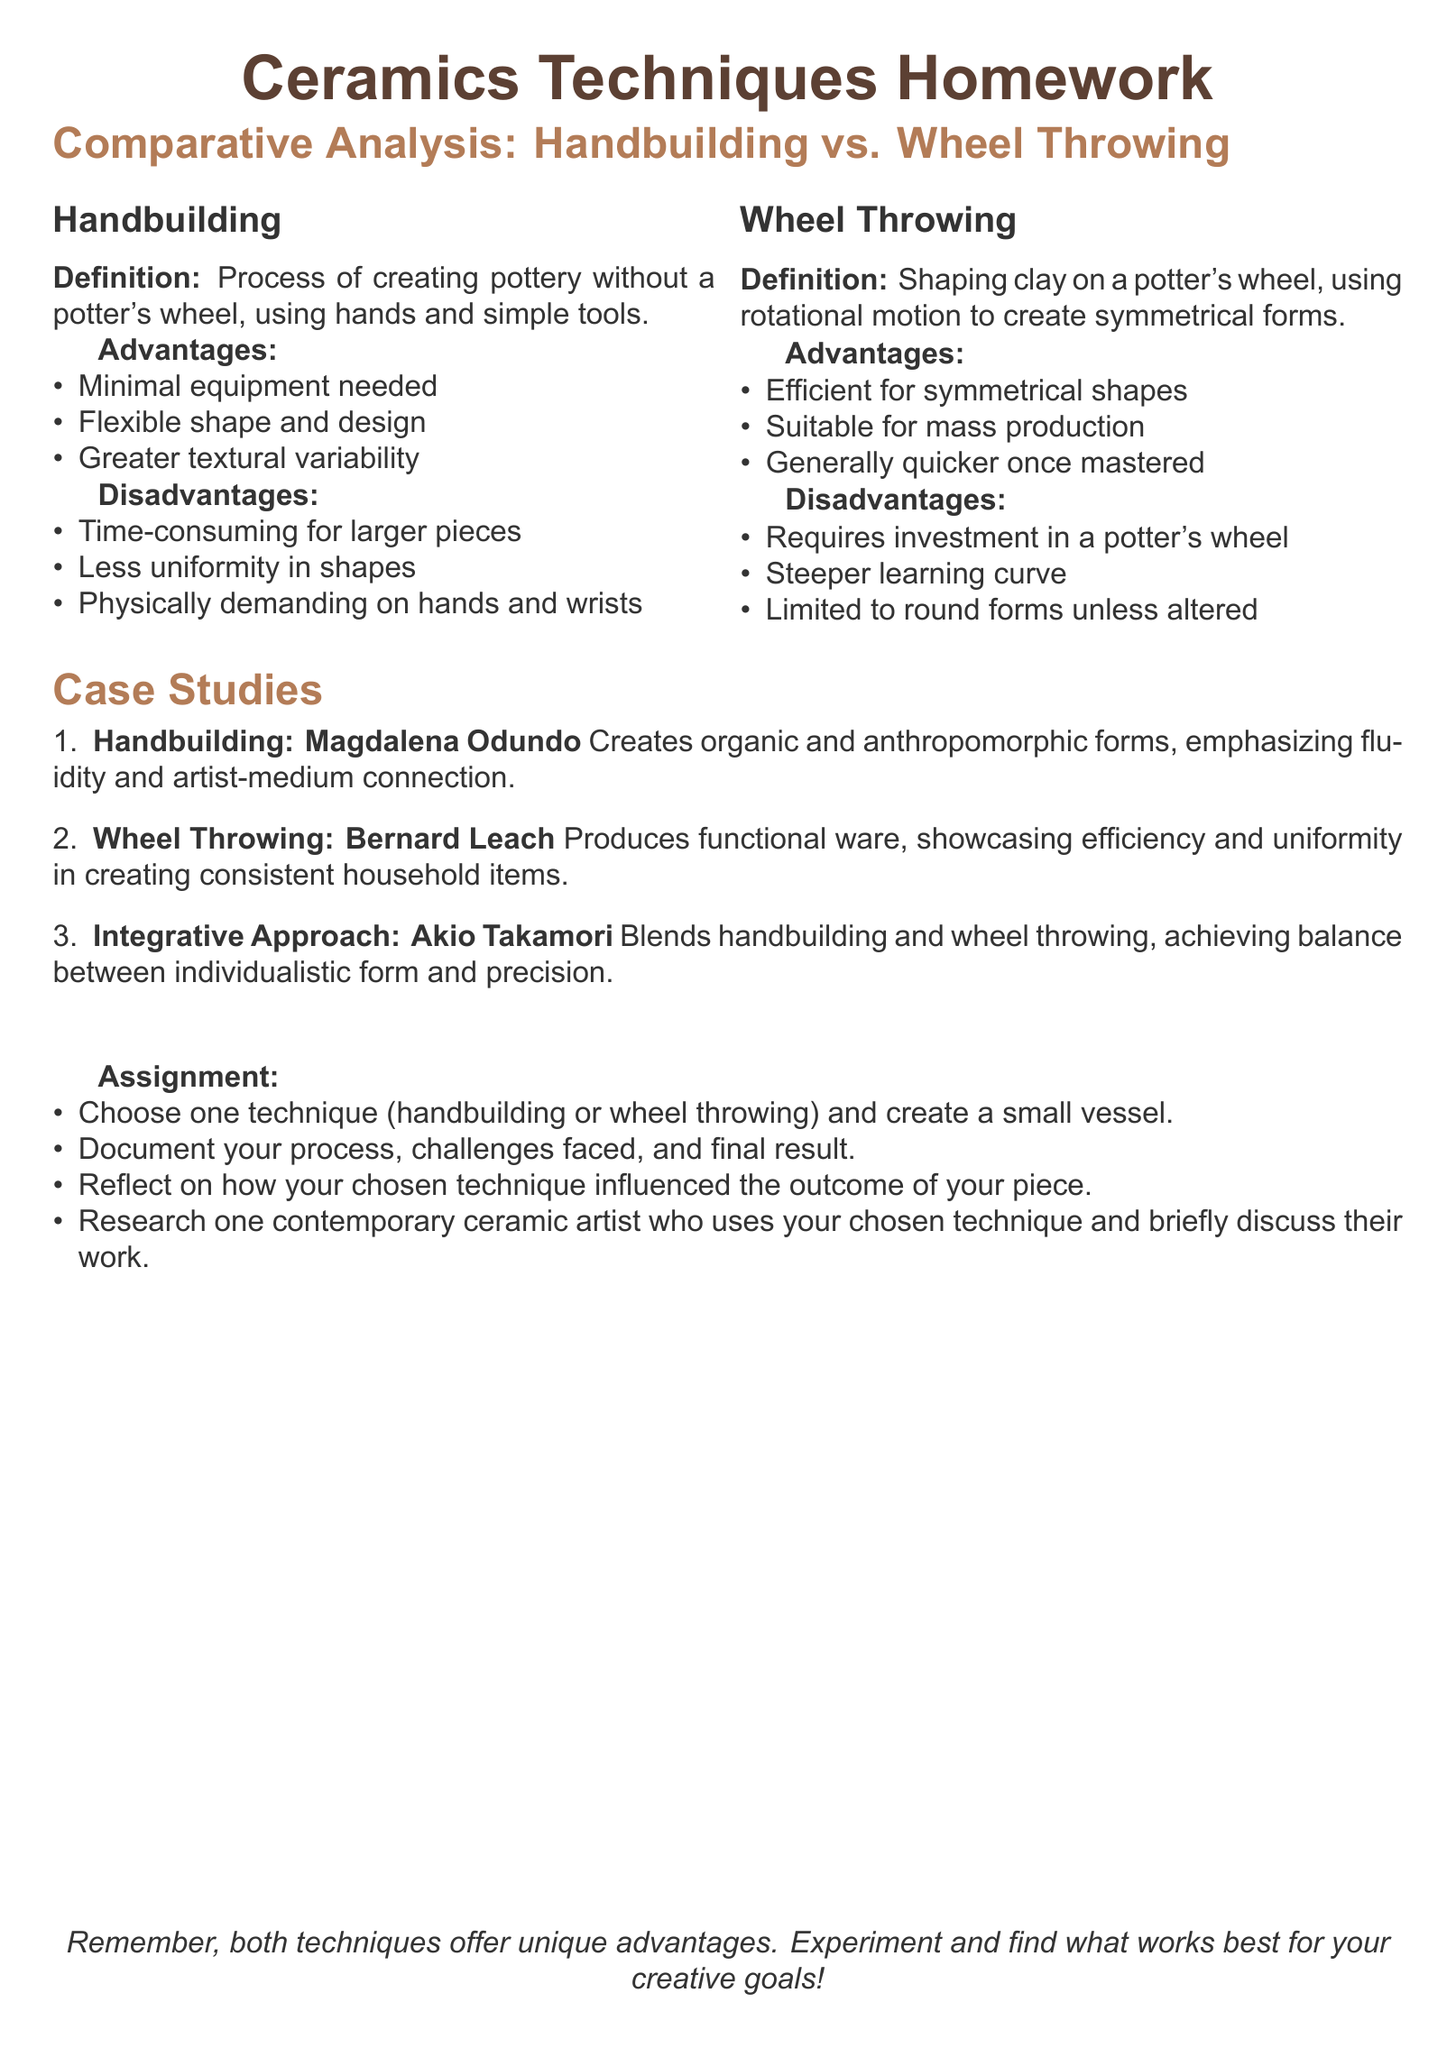What is the definition of handbuilding? Handbuilding is defined in the document as the process of creating pottery without a potter's wheel, using hands and simple tools.
Answer: Process of creating pottery without a potter's wheel, using hands and simple tools What are two disadvantages of wheel throwing? The document lists disadvantages of wheel throwing, including physically demanding on hands and wrists and time-consuming for larger pieces.
Answer: Requires investment in a potter's wheel; Steeper learning curve Who is the contemporary artist associated with handbuilding? The artist Magdalena Odundo is mentioned in the document as a case study for handbuilding techniques.
Answer: Magdalena Odundo What is one advantage of handbuilding? The document states that one advantage of handbuilding is its minimal equipment needed.
Answer: Minimal equipment needed How many artists are included in the case studies section? The document lists three artists as case studies.
Answer: Three What type of approach does Akio Takamori represent? The document describes Akio Takamori's approach as integrative, blending handbuilding and wheel throwing.
Answer: Integrative Approach What is the assignment focusing on? The assignment is aimed at creating a small vessel using handbuilding or wheel throwing techniques.
Answer: Creating a small vessel What is a common characteristic of wheel-thrown pieces? The document states that wheel throwing is efficient for symmetrical shapes.
Answer: Symmetrical shapes What does the document encourage regarding the techniques? The document encourages experimentation and finding what works best for creative goals.
Answer: Experiment and find what works best for your creative goals 